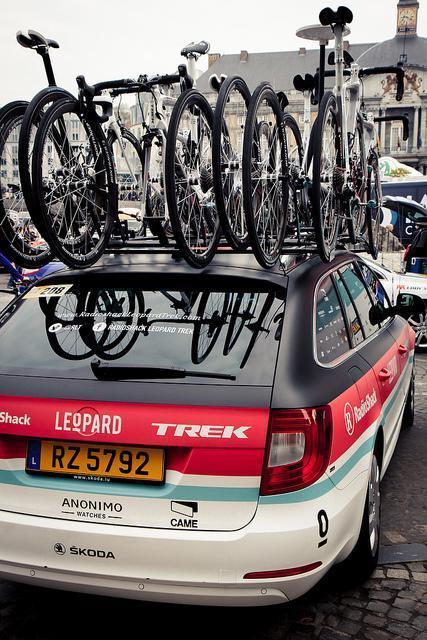How many bicycles can you see?
Give a very brief answer. 8. 